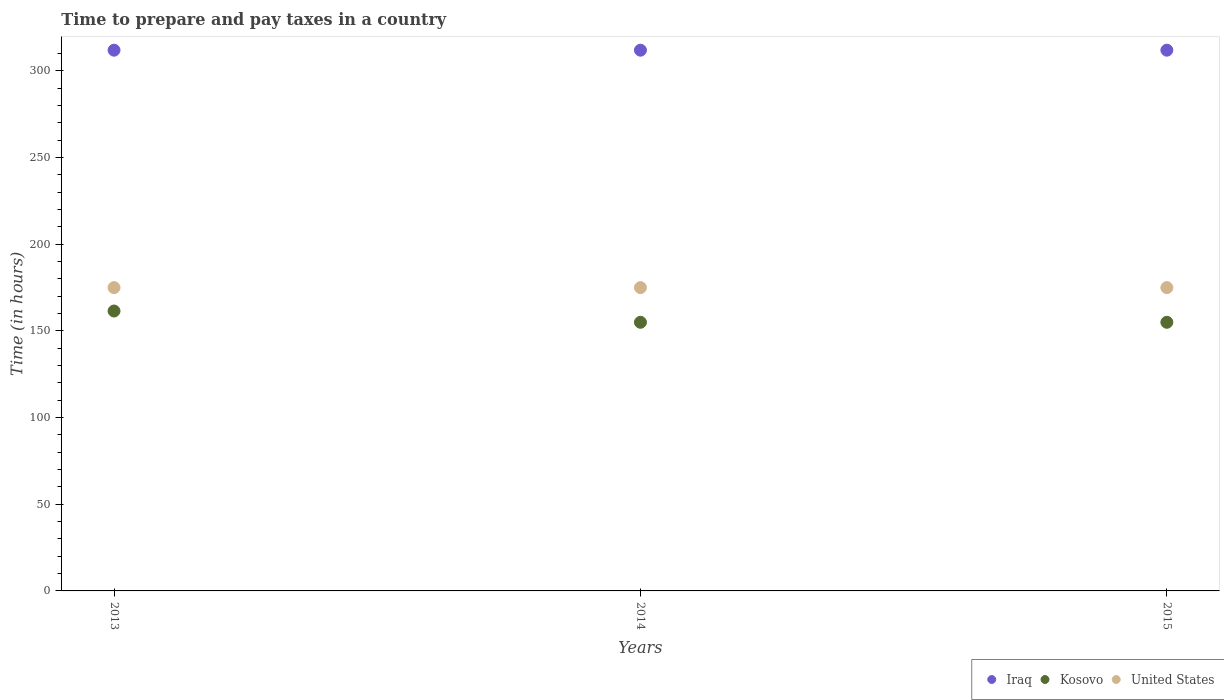Is the number of dotlines equal to the number of legend labels?
Make the answer very short. Yes. What is the number of hours required to prepare and pay taxes in Kosovo in 2013?
Give a very brief answer. 161.5. Across all years, what is the maximum number of hours required to prepare and pay taxes in Iraq?
Ensure brevity in your answer.  312. Across all years, what is the minimum number of hours required to prepare and pay taxes in United States?
Give a very brief answer. 175. What is the total number of hours required to prepare and pay taxes in Kosovo in the graph?
Offer a very short reply. 471.5. What is the difference between the number of hours required to prepare and pay taxes in United States in 2013 and the number of hours required to prepare and pay taxes in Iraq in 2014?
Keep it short and to the point. -137. What is the average number of hours required to prepare and pay taxes in Iraq per year?
Your answer should be compact. 312. In the year 2013, what is the difference between the number of hours required to prepare and pay taxes in Kosovo and number of hours required to prepare and pay taxes in United States?
Provide a short and direct response. -13.5. In how many years, is the number of hours required to prepare and pay taxes in Kosovo greater than 90 hours?
Give a very brief answer. 3. What is the ratio of the number of hours required to prepare and pay taxes in Kosovo in 2014 to that in 2015?
Your answer should be very brief. 1. Is the number of hours required to prepare and pay taxes in Kosovo in 2013 less than that in 2014?
Provide a succinct answer. No. What is the difference between the highest and the second highest number of hours required to prepare and pay taxes in Iraq?
Your response must be concise. 0. In how many years, is the number of hours required to prepare and pay taxes in United States greater than the average number of hours required to prepare and pay taxes in United States taken over all years?
Make the answer very short. 0. Is it the case that in every year, the sum of the number of hours required to prepare and pay taxes in United States and number of hours required to prepare and pay taxes in Iraq  is greater than the number of hours required to prepare and pay taxes in Kosovo?
Provide a succinct answer. Yes. Does the number of hours required to prepare and pay taxes in United States monotonically increase over the years?
Keep it short and to the point. No. Is the number of hours required to prepare and pay taxes in Kosovo strictly greater than the number of hours required to prepare and pay taxes in United States over the years?
Make the answer very short. No. What is the difference between two consecutive major ticks on the Y-axis?
Offer a very short reply. 50. Does the graph contain any zero values?
Offer a very short reply. No. Where does the legend appear in the graph?
Your answer should be compact. Bottom right. How many legend labels are there?
Keep it short and to the point. 3. What is the title of the graph?
Provide a short and direct response. Time to prepare and pay taxes in a country. Does "Sweden" appear as one of the legend labels in the graph?
Offer a very short reply. No. What is the label or title of the X-axis?
Offer a terse response. Years. What is the label or title of the Y-axis?
Offer a very short reply. Time (in hours). What is the Time (in hours) of Iraq in 2013?
Your answer should be compact. 312. What is the Time (in hours) in Kosovo in 2013?
Provide a short and direct response. 161.5. What is the Time (in hours) of United States in 2013?
Offer a very short reply. 175. What is the Time (in hours) of Iraq in 2014?
Offer a very short reply. 312. What is the Time (in hours) of Kosovo in 2014?
Provide a short and direct response. 155. What is the Time (in hours) of United States in 2014?
Offer a terse response. 175. What is the Time (in hours) in Iraq in 2015?
Offer a terse response. 312. What is the Time (in hours) in Kosovo in 2015?
Provide a succinct answer. 155. What is the Time (in hours) of United States in 2015?
Your answer should be compact. 175. Across all years, what is the maximum Time (in hours) in Iraq?
Provide a short and direct response. 312. Across all years, what is the maximum Time (in hours) of Kosovo?
Make the answer very short. 161.5. Across all years, what is the maximum Time (in hours) in United States?
Your answer should be compact. 175. Across all years, what is the minimum Time (in hours) in Iraq?
Offer a terse response. 312. Across all years, what is the minimum Time (in hours) in Kosovo?
Ensure brevity in your answer.  155. Across all years, what is the minimum Time (in hours) in United States?
Your answer should be compact. 175. What is the total Time (in hours) in Iraq in the graph?
Ensure brevity in your answer.  936. What is the total Time (in hours) in Kosovo in the graph?
Offer a terse response. 471.5. What is the total Time (in hours) in United States in the graph?
Your answer should be compact. 525. What is the difference between the Time (in hours) of Iraq in 2013 and that in 2014?
Provide a succinct answer. 0. What is the difference between the Time (in hours) of Kosovo in 2013 and that in 2014?
Ensure brevity in your answer.  6.5. What is the difference between the Time (in hours) in United States in 2013 and that in 2014?
Give a very brief answer. 0. What is the difference between the Time (in hours) in United States in 2013 and that in 2015?
Your response must be concise. 0. What is the difference between the Time (in hours) in Iraq in 2014 and that in 2015?
Provide a short and direct response. 0. What is the difference between the Time (in hours) of United States in 2014 and that in 2015?
Keep it short and to the point. 0. What is the difference between the Time (in hours) in Iraq in 2013 and the Time (in hours) in Kosovo in 2014?
Give a very brief answer. 157. What is the difference between the Time (in hours) in Iraq in 2013 and the Time (in hours) in United States in 2014?
Give a very brief answer. 137. What is the difference between the Time (in hours) of Iraq in 2013 and the Time (in hours) of Kosovo in 2015?
Ensure brevity in your answer.  157. What is the difference between the Time (in hours) in Iraq in 2013 and the Time (in hours) in United States in 2015?
Offer a very short reply. 137. What is the difference between the Time (in hours) in Kosovo in 2013 and the Time (in hours) in United States in 2015?
Your answer should be compact. -13.5. What is the difference between the Time (in hours) in Iraq in 2014 and the Time (in hours) in Kosovo in 2015?
Offer a very short reply. 157. What is the difference between the Time (in hours) in Iraq in 2014 and the Time (in hours) in United States in 2015?
Make the answer very short. 137. What is the difference between the Time (in hours) in Kosovo in 2014 and the Time (in hours) in United States in 2015?
Offer a terse response. -20. What is the average Time (in hours) of Iraq per year?
Ensure brevity in your answer.  312. What is the average Time (in hours) of Kosovo per year?
Make the answer very short. 157.17. What is the average Time (in hours) in United States per year?
Provide a succinct answer. 175. In the year 2013, what is the difference between the Time (in hours) of Iraq and Time (in hours) of Kosovo?
Your answer should be compact. 150.5. In the year 2013, what is the difference between the Time (in hours) of Iraq and Time (in hours) of United States?
Your response must be concise. 137. In the year 2014, what is the difference between the Time (in hours) of Iraq and Time (in hours) of Kosovo?
Provide a short and direct response. 157. In the year 2014, what is the difference between the Time (in hours) of Iraq and Time (in hours) of United States?
Keep it short and to the point. 137. In the year 2015, what is the difference between the Time (in hours) in Iraq and Time (in hours) in Kosovo?
Give a very brief answer. 157. In the year 2015, what is the difference between the Time (in hours) of Iraq and Time (in hours) of United States?
Make the answer very short. 137. In the year 2015, what is the difference between the Time (in hours) in Kosovo and Time (in hours) in United States?
Offer a very short reply. -20. What is the ratio of the Time (in hours) in Kosovo in 2013 to that in 2014?
Ensure brevity in your answer.  1.04. What is the ratio of the Time (in hours) of Iraq in 2013 to that in 2015?
Offer a very short reply. 1. What is the ratio of the Time (in hours) in Kosovo in 2013 to that in 2015?
Keep it short and to the point. 1.04. What is the ratio of the Time (in hours) of United States in 2013 to that in 2015?
Provide a short and direct response. 1. What is the ratio of the Time (in hours) in Iraq in 2014 to that in 2015?
Make the answer very short. 1. What is the ratio of the Time (in hours) of Kosovo in 2014 to that in 2015?
Keep it short and to the point. 1. What is the ratio of the Time (in hours) in United States in 2014 to that in 2015?
Offer a terse response. 1. What is the difference between the highest and the second highest Time (in hours) in United States?
Offer a terse response. 0. What is the difference between the highest and the lowest Time (in hours) of United States?
Offer a very short reply. 0. 